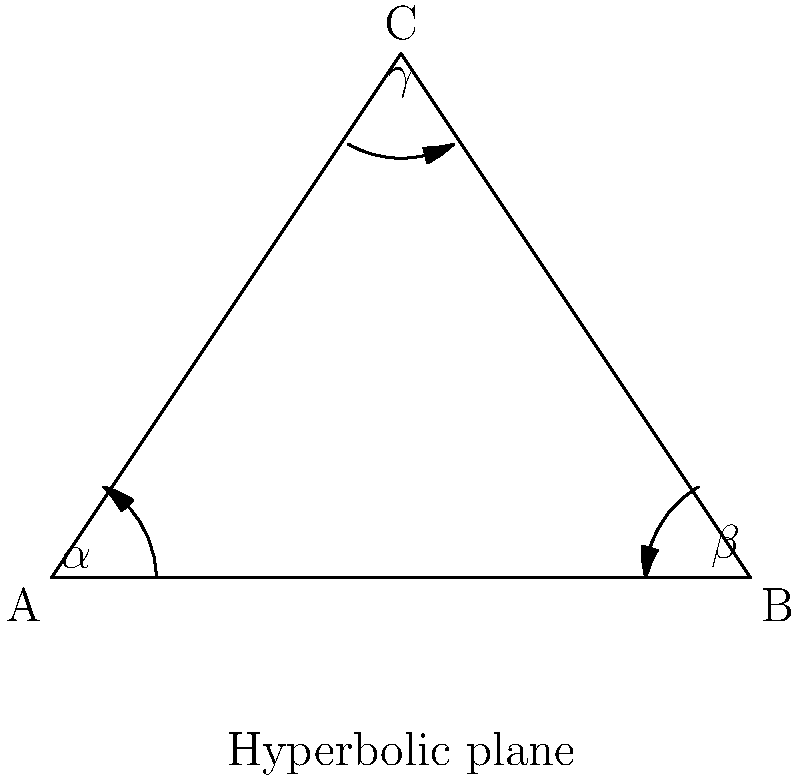In a hyperbolic plane, the sum of the interior angles of a triangle is always less than 180°. If you're creating a playlist to help someone understand non-Euclidean geometry, how would you explain the relationship between the angles $\alpha$, $\beta$, and $\gamma$ in the triangle ABC shown above, and the area of the triangle? To explain this concept in the context of creating a supportive playlist, we can break it down into steps:

1) In Euclidean geometry, the sum of interior angles of a triangle is always 180°. However, in hyperbolic geometry, this sum is always less than 180°.

2) The difference between 180° and the sum of the angles is directly related to the area of the triangle. This relationship is given by the Gauss-Bonnet formula:

   $$\alpha + \beta + \gamma = \pi - kA$$

   Where $\alpha$, $\beta$, and $\gamma$ are the angles of the triangle, $A$ is the area, and $k$ is the Gaussian curvature of the hyperbolic plane (which is negative).

3) Rearranging this formula, we get:

   $$A = \frac{\pi - (\alpha + \beta + \gamma)}{|k|}$$

4) This means that the larger the area of the triangle, the smaller the sum of its angles will be.

5) Conversely, as the triangle gets smaller, the sum of its angles approaches 180° (π radians), just like in Euclidean geometry.

6) This concept could be related to emotional support by explaining that just as the geometry of a space affects the properties of shapes within it, our environment and perspective can shape our emotional experiences.
Answer: $A = \frac{\pi - (\alpha + \beta + \gamma)}{|k|}$, where $A$ is area, $\alpha$, $\beta$, $\gamma$ are angles, and $k$ is negative Gaussian curvature. 